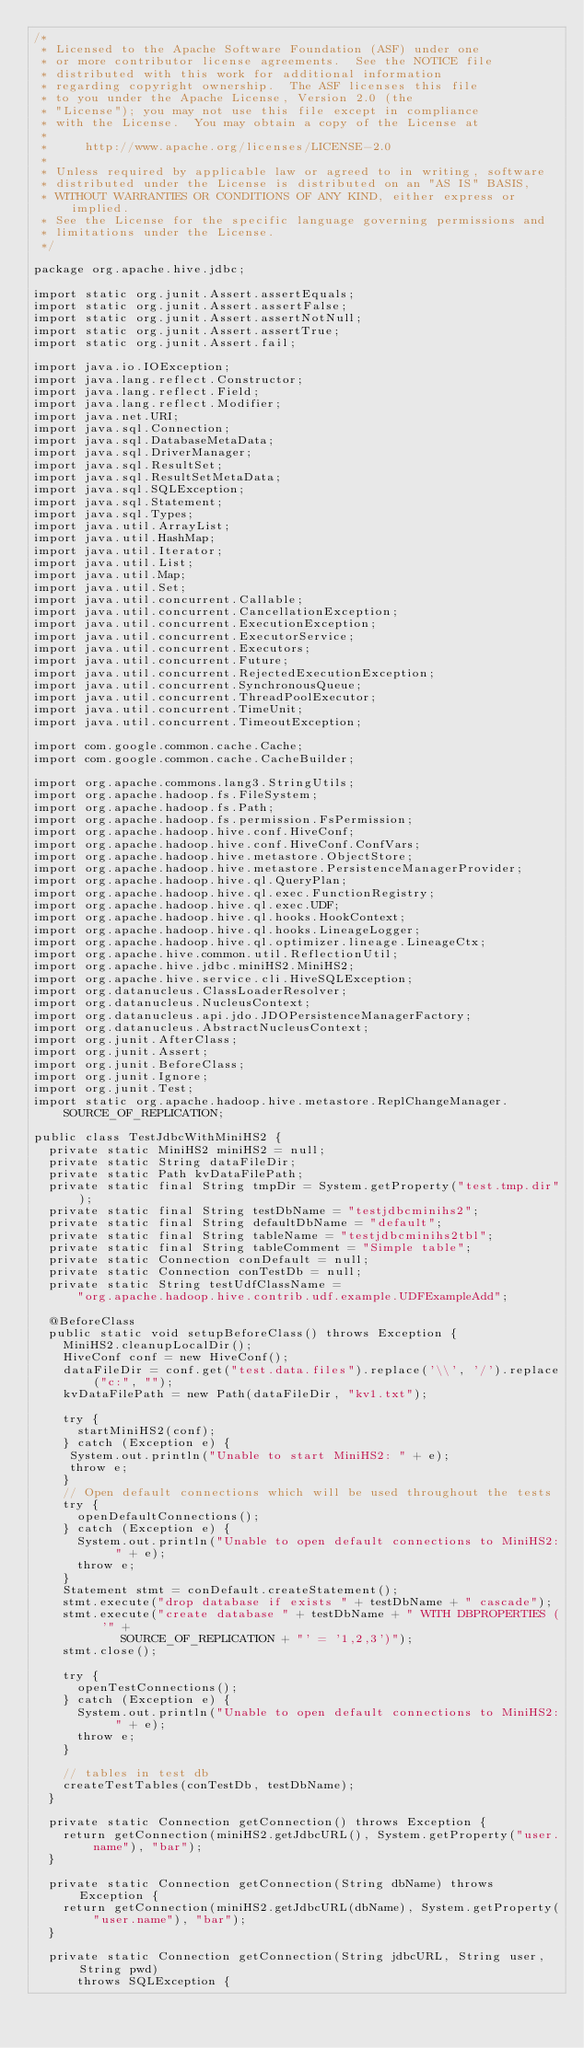Convert code to text. <code><loc_0><loc_0><loc_500><loc_500><_Java_>/*
 * Licensed to the Apache Software Foundation (ASF) under one
 * or more contributor license agreements.  See the NOTICE file
 * distributed with this work for additional information
 * regarding copyright ownership.  The ASF licenses this file
 * to you under the Apache License, Version 2.0 (the
 * "License"); you may not use this file except in compliance
 * with the License.  You may obtain a copy of the License at
 *
 *     http://www.apache.org/licenses/LICENSE-2.0
 *
 * Unless required by applicable law or agreed to in writing, software
 * distributed under the License is distributed on an "AS IS" BASIS,
 * WITHOUT WARRANTIES OR CONDITIONS OF ANY KIND, either express or implied.
 * See the License for the specific language governing permissions and
 * limitations under the License.
 */

package org.apache.hive.jdbc;

import static org.junit.Assert.assertEquals;
import static org.junit.Assert.assertFalse;
import static org.junit.Assert.assertNotNull;
import static org.junit.Assert.assertTrue;
import static org.junit.Assert.fail;

import java.io.IOException;
import java.lang.reflect.Constructor;
import java.lang.reflect.Field;
import java.lang.reflect.Modifier;
import java.net.URI;
import java.sql.Connection;
import java.sql.DatabaseMetaData;
import java.sql.DriverManager;
import java.sql.ResultSet;
import java.sql.ResultSetMetaData;
import java.sql.SQLException;
import java.sql.Statement;
import java.sql.Types;
import java.util.ArrayList;
import java.util.HashMap;
import java.util.Iterator;
import java.util.List;
import java.util.Map;
import java.util.Set;
import java.util.concurrent.Callable;
import java.util.concurrent.CancellationException;
import java.util.concurrent.ExecutionException;
import java.util.concurrent.ExecutorService;
import java.util.concurrent.Executors;
import java.util.concurrent.Future;
import java.util.concurrent.RejectedExecutionException;
import java.util.concurrent.SynchronousQueue;
import java.util.concurrent.ThreadPoolExecutor;
import java.util.concurrent.TimeUnit;
import java.util.concurrent.TimeoutException;

import com.google.common.cache.Cache;
import com.google.common.cache.CacheBuilder;

import org.apache.commons.lang3.StringUtils;
import org.apache.hadoop.fs.FileSystem;
import org.apache.hadoop.fs.Path;
import org.apache.hadoop.fs.permission.FsPermission;
import org.apache.hadoop.hive.conf.HiveConf;
import org.apache.hadoop.hive.conf.HiveConf.ConfVars;
import org.apache.hadoop.hive.metastore.ObjectStore;
import org.apache.hadoop.hive.metastore.PersistenceManagerProvider;
import org.apache.hadoop.hive.ql.QueryPlan;
import org.apache.hadoop.hive.ql.exec.FunctionRegistry;
import org.apache.hadoop.hive.ql.exec.UDF;
import org.apache.hadoop.hive.ql.hooks.HookContext;
import org.apache.hadoop.hive.ql.hooks.LineageLogger;
import org.apache.hadoop.hive.ql.optimizer.lineage.LineageCtx;
import org.apache.hive.common.util.ReflectionUtil;
import org.apache.hive.jdbc.miniHS2.MiniHS2;
import org.apache.hive.service.cli.HiveSQLException;
import org.datanucleus.ClassLoaderResolver;
import org.datanucleus.NucleusContext;
import org.datanucleus.api.jdo.JDOPersistenceManagerFactory;
import org.datanucleus.AbstractNucleusContext;
import org.junit.AfterClass;
import org.junit.Assert;
import org.junit.BeforeClass;
import org.junit.Ignore;
import org.junit.Test;
import static org.apache.hadoop.hive.metastore.ReplChangeManager.SOURCE_OF_REPLICATION;

public class TestJdbcWithMiniHS2 {
  private static MiniHS2 miniHS2 = null;
  private static String dataFileDir;
  private static Path kvDataFilePath;
  private static final String tmpDir = System.getProperty("test.tmp.dir");
  private static final String testDbName = "testjdbcminihs2";
  private static final String defaultDbName = "default";
  private static final String tableName = "testjdbcminihs2tbl";
  private static final String tableComment = "Simple table";
  private static Connection conDefault = null;
  private static Connection conTestDb = null;
  private static String testUdfClassName =
      "org.apache.hadoop.hive.contrib.udf.example.UDFExampleAdd";

  @BeforeClass
  public static void setupBeforeClass() throws Exception {
    MiniHS2.cleanupLocalDir();
    HiveConf conf = new HiveConf();
    dataFileDir = conf.get("test.data.files").replace('\\', '/').replace("c:", "");
    kvDataFilePath = new Path(dataFileDir, "kv1.txt");

    try {
      startMiniHS2(conf);
    } catch (Exception e) {
     System.out.println("Unable to start MiniHS2: " + e);
     throw e;
    }
    // Open default connections which will be used throughout the tests
    try {
      openDefaultConnections();
    } catch (Exception e) {
      System.out.println("Unable to open default connections to MiniHS2: " + e);
      throw e;
    }
    Statement stmt = conDefault.createStatement();
    stmt.execute("drop database if exists " + testDbName + " cascade");
    stmt.execute("create database " + testDbName + " WITH DBPROPERTIES ( '" +
            SOURCE_OF_REPLICATION + "' = '1,2,3')");
    stmt.close();

    try {
      openTestConnections();
    } catch (Exception e) {
      System.out.println("Unable to open default connections to MiniHS2: " + e);
      throw e;
    }

    // tables in test db
    createTestTables(conTestDb, testDbName);
  }

  private static Connection getConnection() throws Exception {
    return getConnection(miniHS2.getJdbcURL(), System.getProperty("user.name"), "bar");
  }

  private static Connection getConnection(String dbName) throws Exception {
    return getConnection(miniHS2.getJdbcURL(dbName), System.getProperty("user.name"), "bar");
  }

  private static Connection getConnection(String jdbcURL, String user, String pwd)
      throws SQLException {</code> 